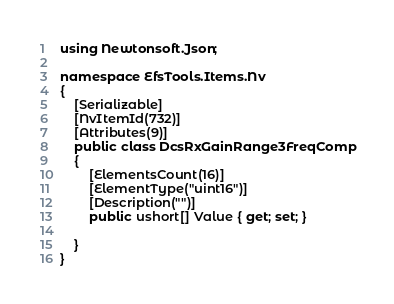Convert code to text. <code><loc_0><loc_0><loc_500><loc_500><_C#_>using Newtonsoft.Json;

namespace EfsTools.Items.Nv
{
    [Serializable]
    [NvItemId(732)]
    [Attributes(9)]
    public class DcsRxGainRange3FreqComp
    {
        [ElementsCount(16)]
        [ElementType("uint16")]
        [Description("")]
        public ushort[] Value { get; set; }
        
    }
}
</code> 